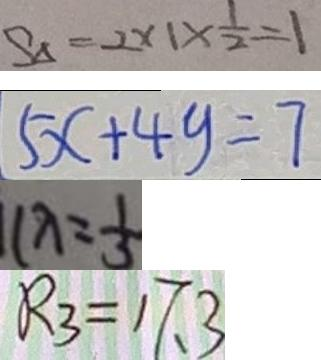<formula> <loc_0><loc_0><loc_500><loc_500>S _ { \Delta } = 2 \times 1 \times \frac { 1 } { 2 } = 1 
 5 x + 4 y = 7 
 1 \lambda = \frac { 1 } { 3 } 
 R _ { 3 } = 1 7 . 3</formula> 